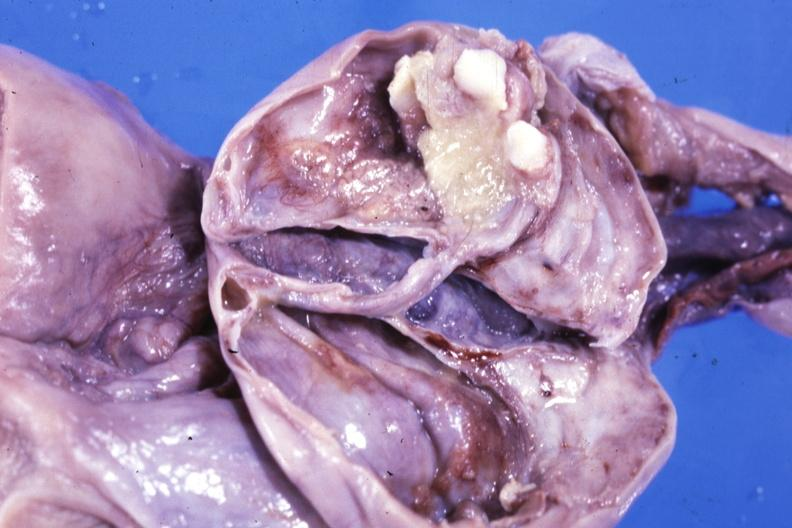what is present?
Answer the question using a single word or phrase. Ovary 